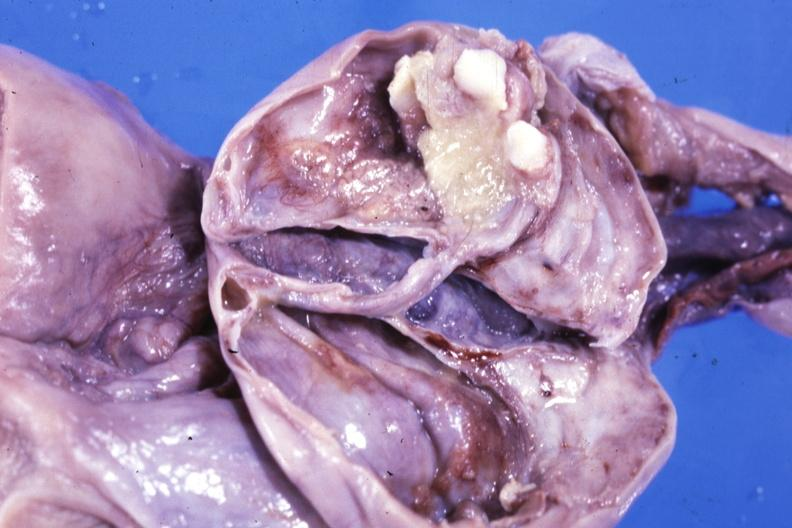what is present?
Answer the question using a single word or phrase. Ovary 